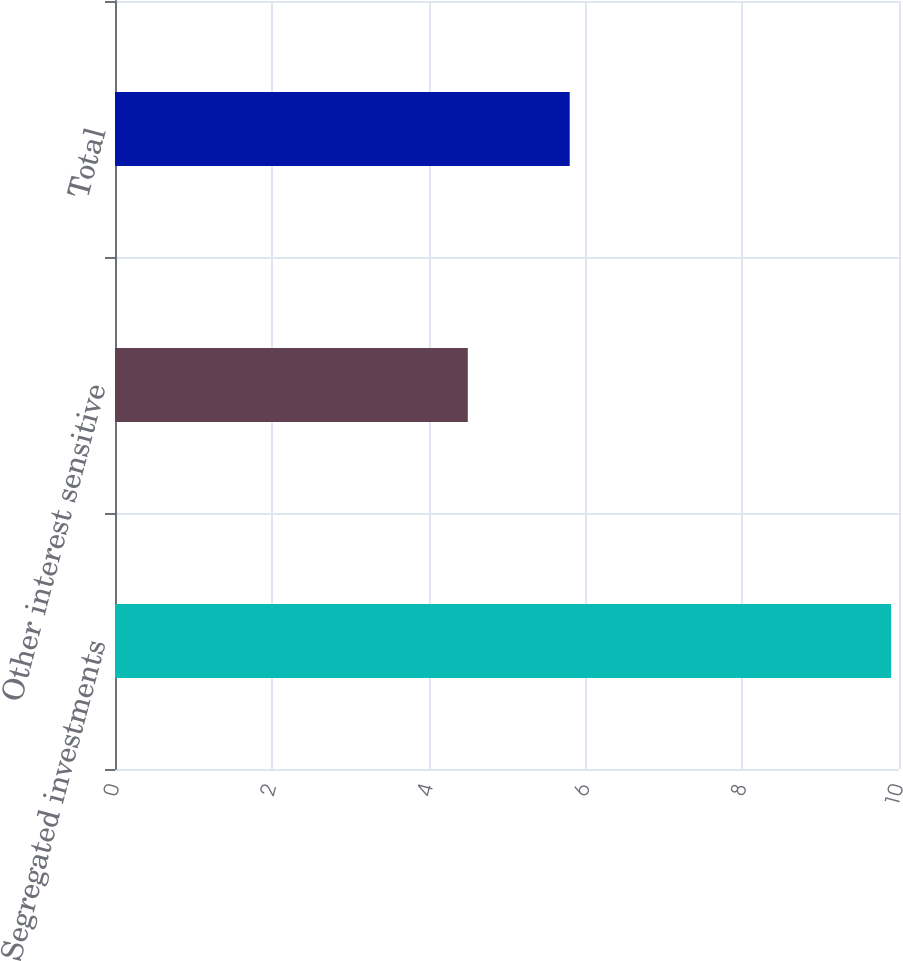<chart> <loc_0><loc_0><loc_500><loc_500><bar_chart><fcel>Segregated investments<fcel>Other interest sensitive<fcel>Total<nl><fcel>9.9<fcel>4.5<fcel>5.8<nl></chart> 